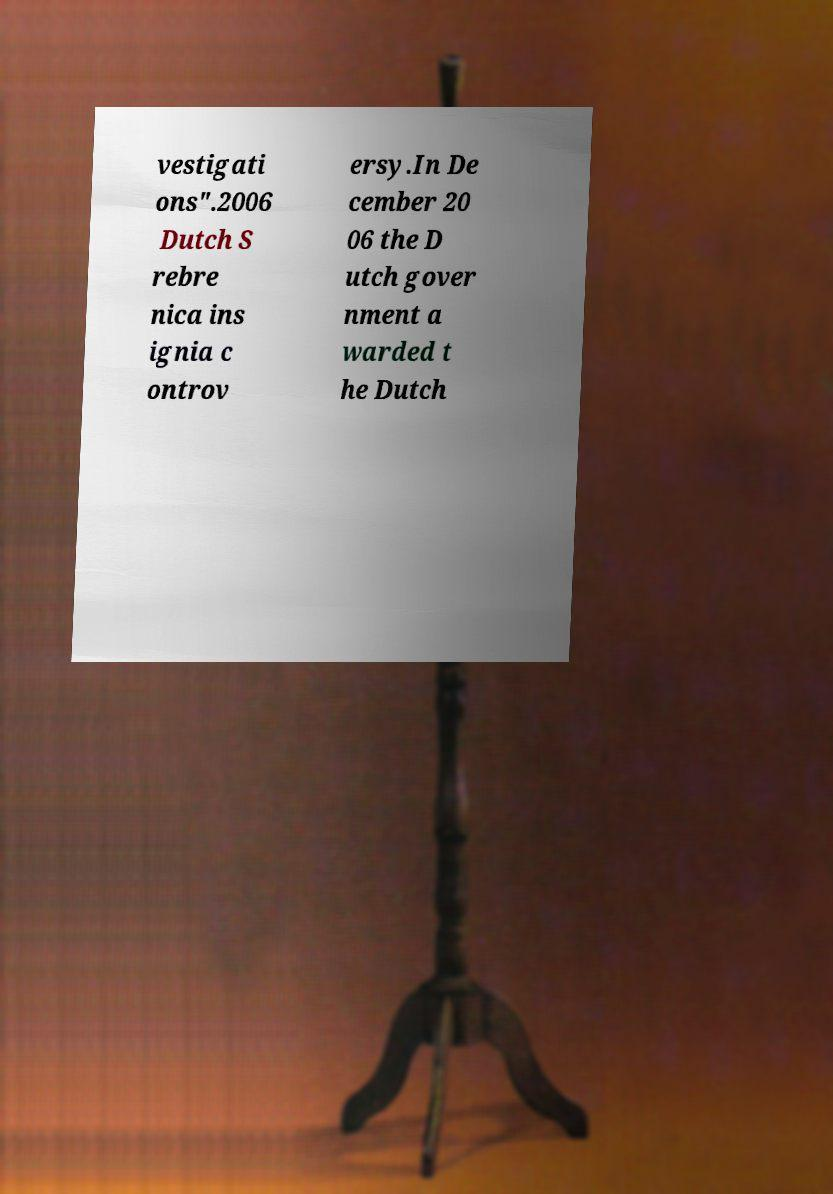There's text embedded in this image that I need extracted. Can you transcribe it verbatim? vestigati ons".2006 Dutch S rebre nica ins ignia c ontrov ersy.In De cember 20 06 the D utch gover nment a warded t he Dutch 